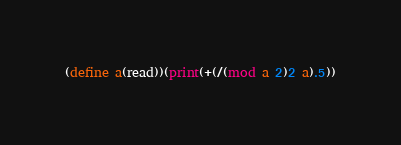Convert code to text. <code><loc_0><loc_0><loc_500><loc_500><_Scheme_>(define a(read))(print(+(/(mod a 2)2 a).5))</code> 